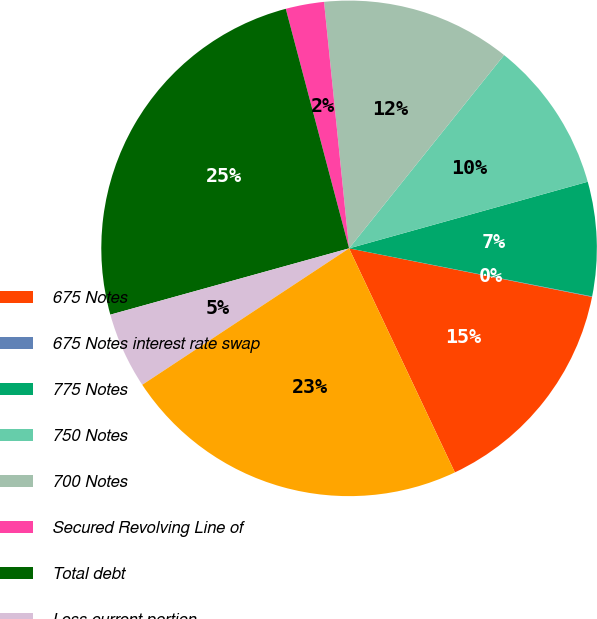Convert chart to OTSL. <chart><loc_0><loc_0><loc_500><loc_500><pie_chart><fcel>675 Notes<fcel>675 Notes interest rate swap<fcel>775 Notes<fcel>750 Notes<fcel>700 Notes<fcel>Secured Revolving Line of<fcel>Total debt<fcel>Less current portion<fcel>Total debt less current<nl><fcel>14.84%<fcel>0.03%<fcel>7.44%<fcel>9.91%<fcel>12.37%<fcel>2.5%<fcel>25.2%<fcel>4.97%<fcel>22.74%<nl></chart> 